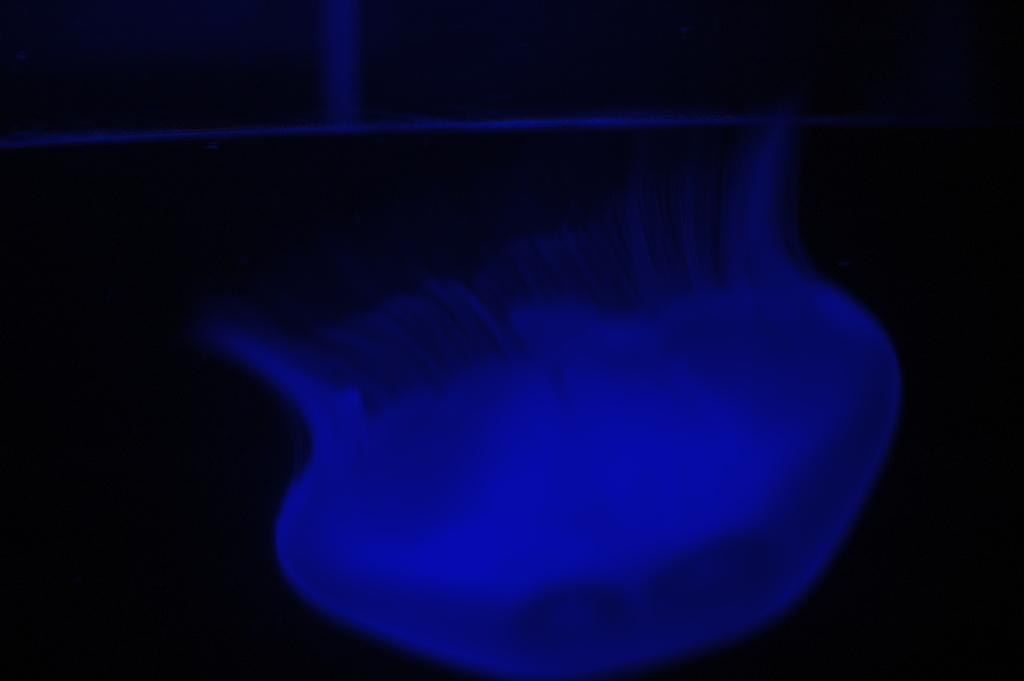What is the main subject of the image? There is a jellyfish in the image. What can be observed about the background of the image? The background of the image is dark. How many bikes are being ridden by the jellyfish in the image? There are no bikes present in the image, and the jellyfish is not shown riding anything. 